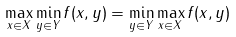Convert formula to latex. <formula><loc_0><loc_0><loc_500><loc_500>\max _ { x \in X } \min _ { y \in Y } f ( x , y ) = \min _ { y \in Y } \max _ { x \in X } f ( x , y )</formula> 